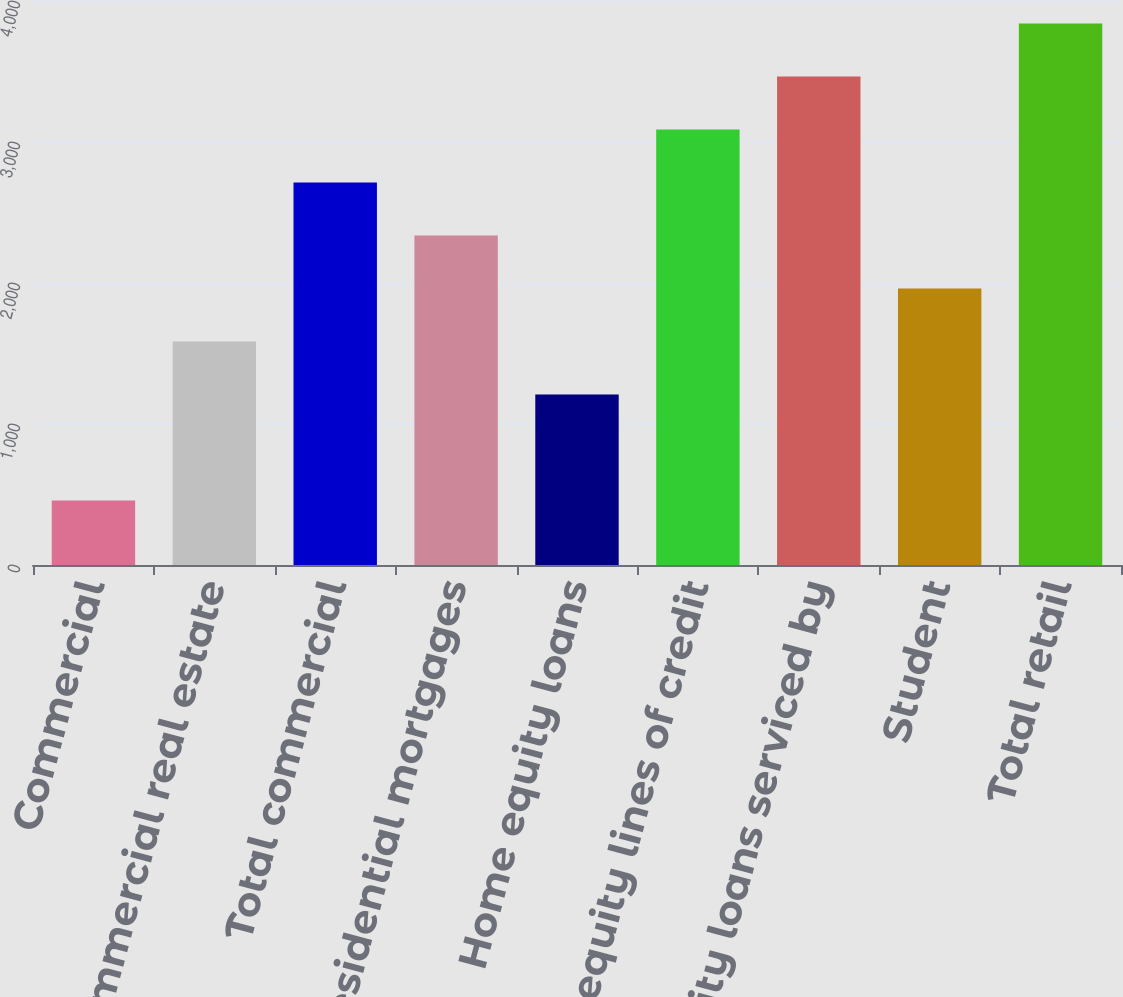<chart> <loc_0><loc_0><loc_500><loc_500><bar_chart><fcel>Commercial<fcel>Commercial real estate<fcel>Total commercial<fcel>Residential mortgages<fcel>Home equity loans<fcel>Home equity lines of credit<fcel>Home equity loans serviced by<fcel>Student<fcel>Total retail<nl><fcel>457<fcel>1585<fcel>2713<fcel>2337<fcel>1209<fcel>3089<fcel>3465<fcel>1961<fcel>3841<nl></chart> 